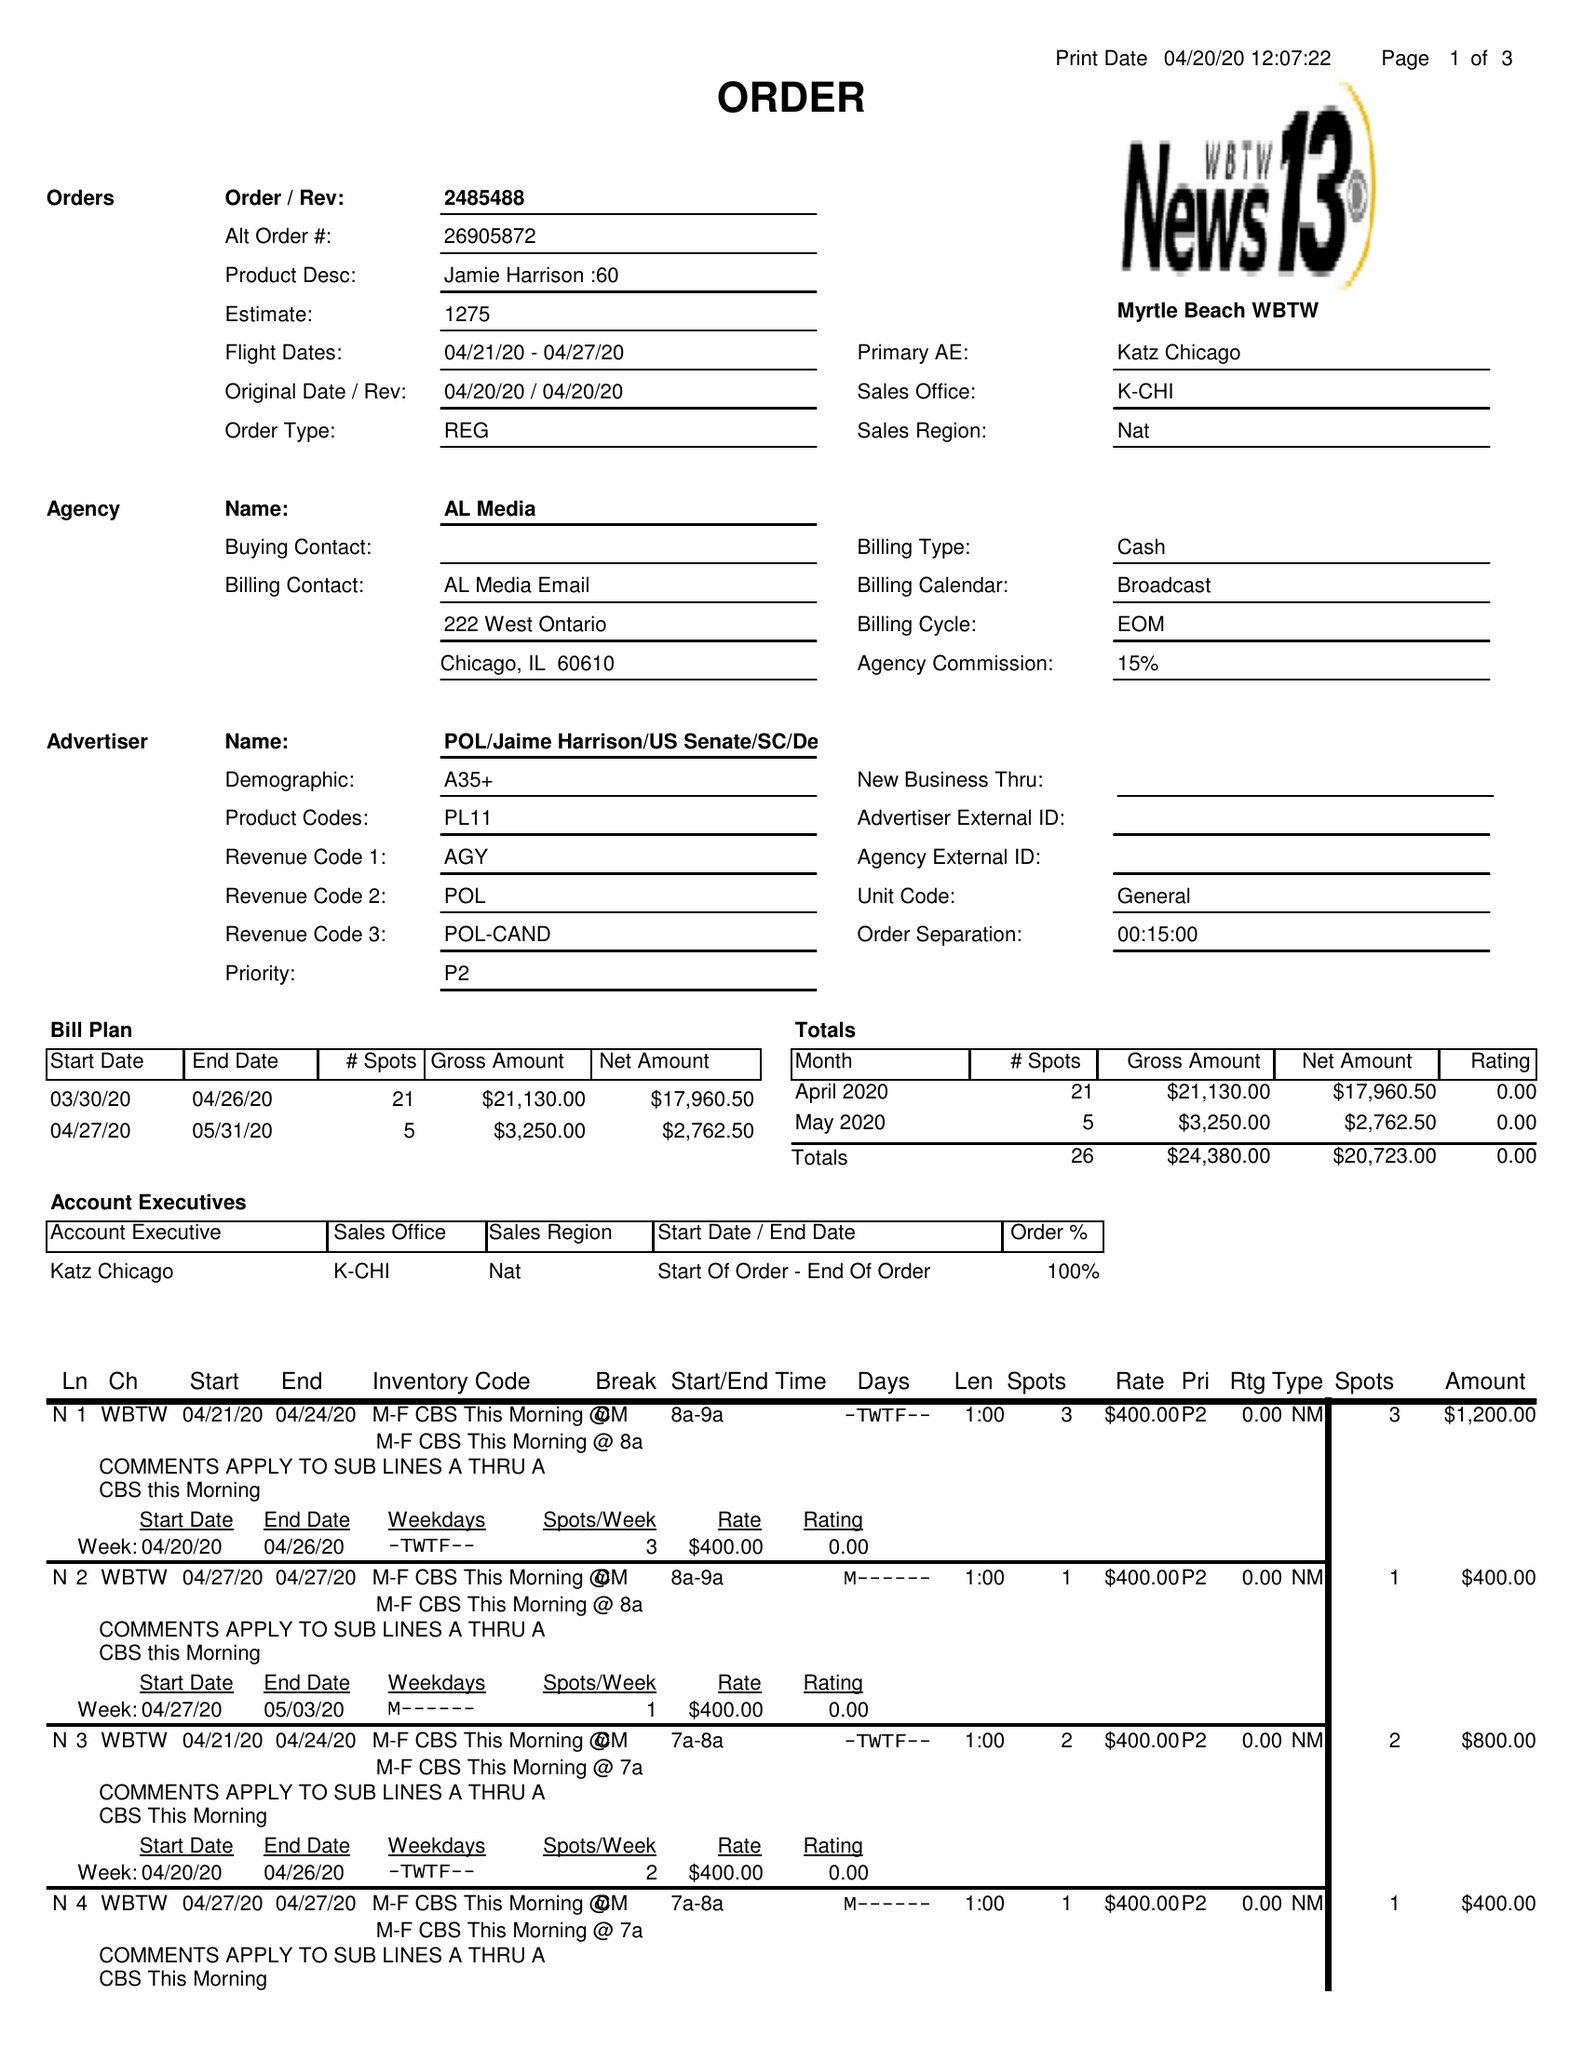What is the value for the flight_to?
Answer the question using a single word or phrase. 04/27/20 